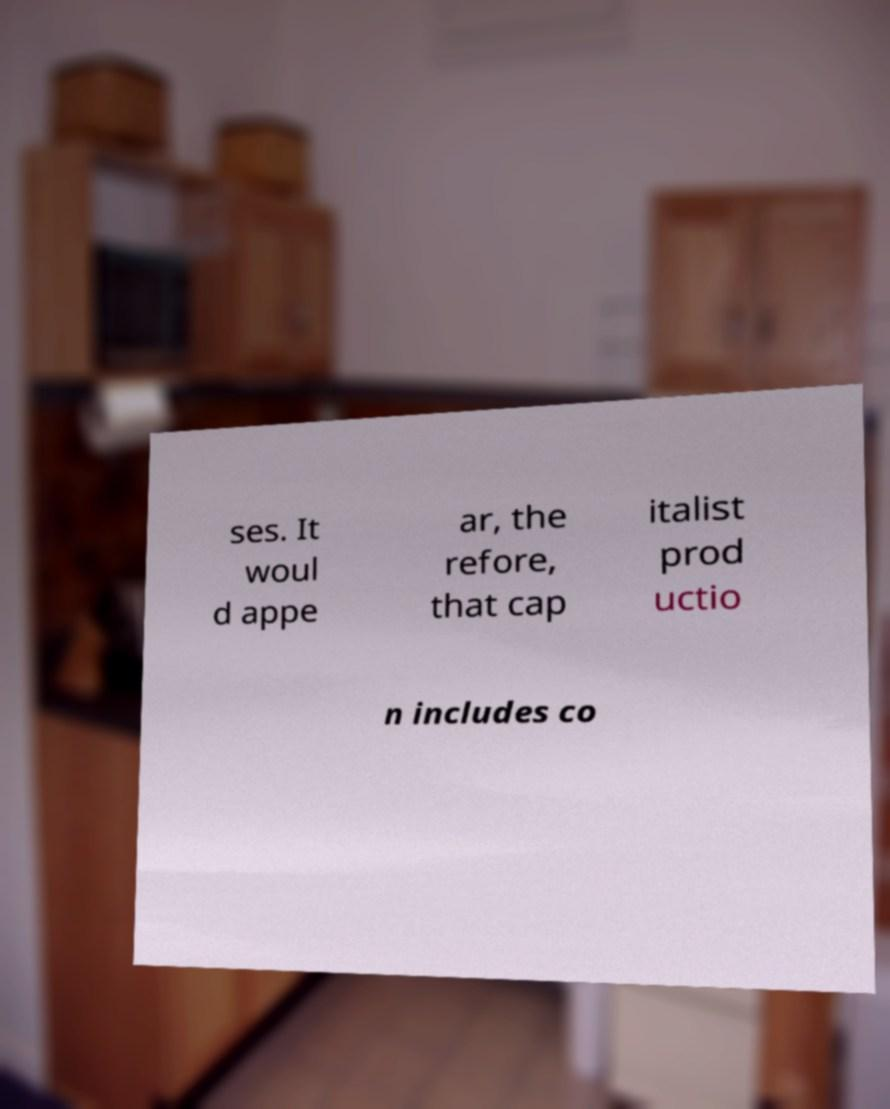Can you accurately transcribe the text from the provided image for me? ses. It woul d appe ar, the refore, that cap italist prod uctio n includes co 